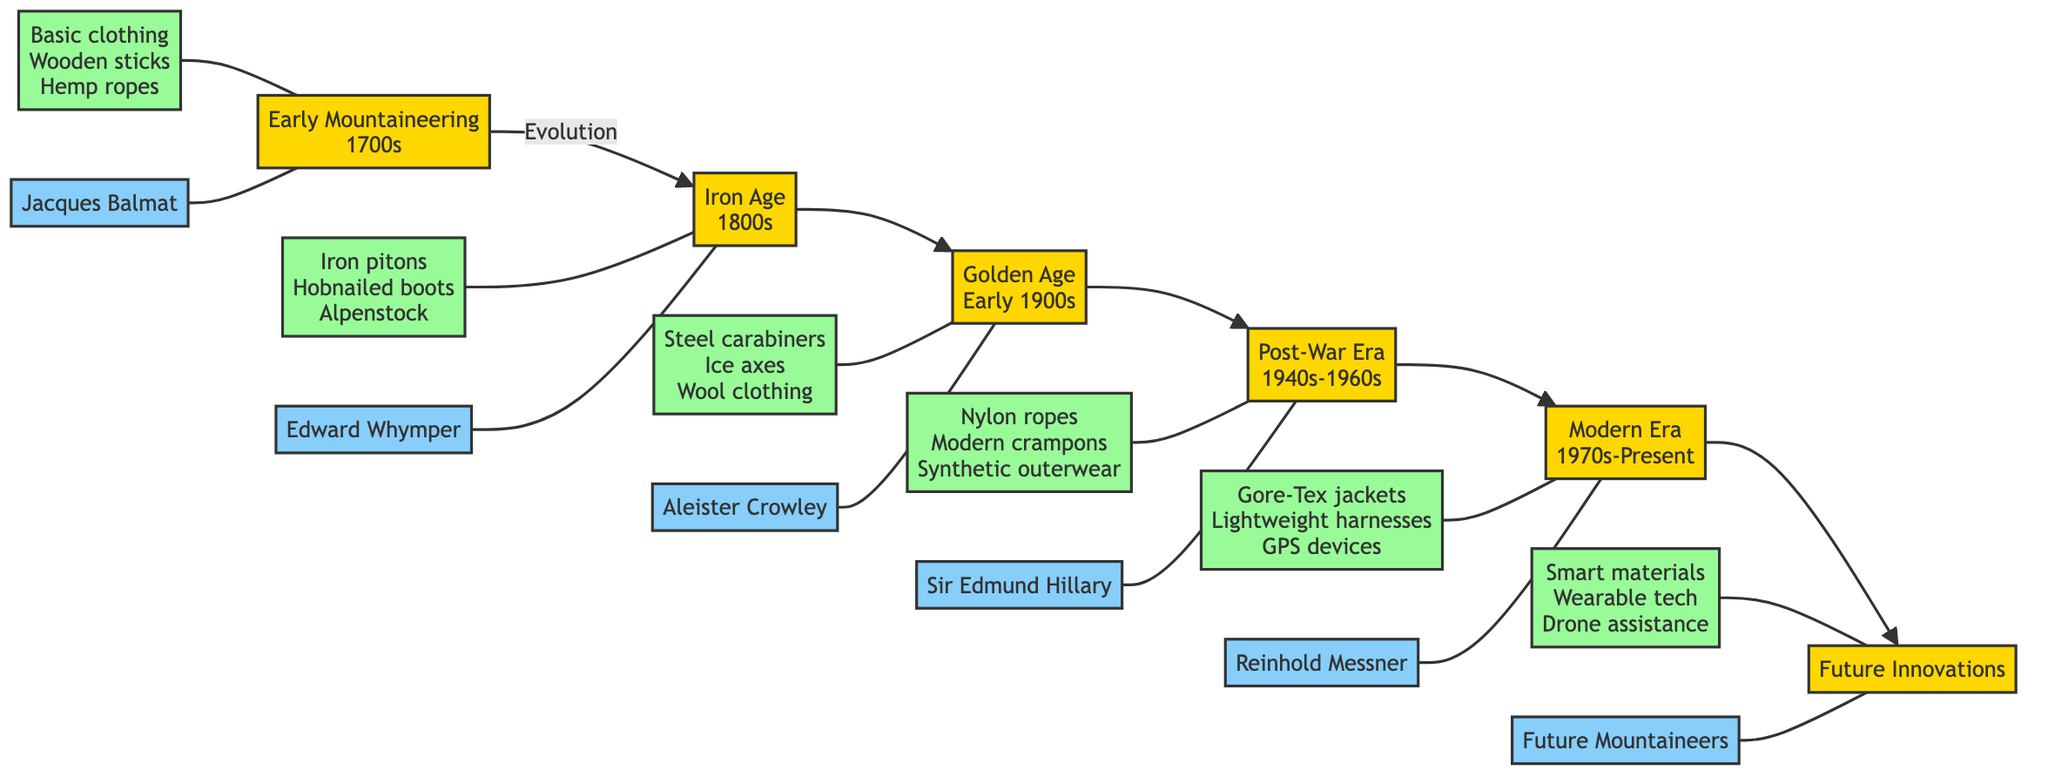What is the first documented summit in the diagram? The flowchart indicates that the first documented summit is Mont Blanc in 1786 under Early Mountaineering, which is highlighted as a significant event.
Answer: Mont Blanc Who is the key figure of the Iron Age? From the diagram, the key figure listed for the Iron Age (1800s) is Edward Whymper, who is connected to this era via a node.
Answer: Edward Whymper How many eras are depicted in the diagram? By counting the distinct eras, there are a total of six eras shown in the flowchart, from Early Mountaineering to Future Innovations.
Answer: Six What gear was used during the Post-War Era? The gear associated with the Post-War Era (1940s-1960s) includes nylon ropes, modern crampons, and synthetic outerwear, which are encapsulated in a specific node.
Answer: Nylon ropes, modern crampons, synthetic outerwear What relationship exists between the Modern Era and Future Innovations? The flowchart illustrates a direct evolution relationship, where Modern Era flows into Future Innovations, indicating progress and development from one to the next.
Answer: Evolution Which era had advancements in high-tech materials? The diagram describes the Modern Era (1970s-Present) as the period characterized by the integration of high-tech materials and gear, making it the relevant era for this question.
Answer: Modern Era What is one example of gear listed in the Golden Age? The flowchart specifies that during the Golden Age (Early 1900s), steel carabiners are mentioned among other gear, making it a representative example from this period.
Answer: Steel carabiners Who represents the key figure in Future Innovations? The diagram states that the key figure for Future Innovations is labeled as Future Mountaineers, indicating that this refers to mountaineers yet to come.
Answer: Future Mountaineers Which gear is associated with Early Mountaineering? The gear listed under Early Mountaineering (1700s) includes basic clothing, wooden sticks, and hemp ropes, which are directly connected in the flowchart.
Answer: Basic clothing, wooden sticks, hemp ropes 